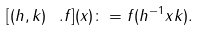Convert formula to latex. <formula><loc_0><loc_0><loc_500><loc_500>[ ( h , k ) \ . f ] ( x ) \colon = f ( h ^ { - 1 } x k ) .</formula> 